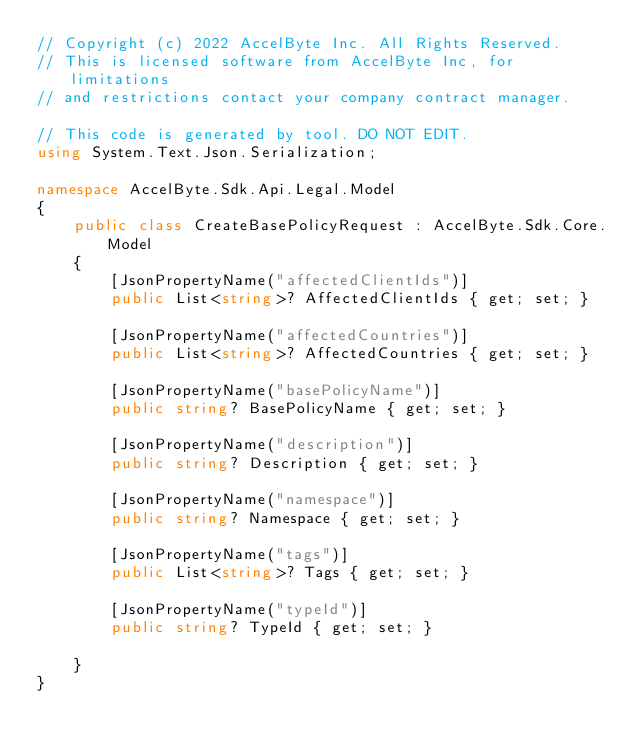<code> <loc_0><loc_0><loc_500><loc_500><_C#_>// Copyright (c) 2022 AccelByte Inc. All Rights Reserved.
// This is licensed software from AccelByte Inc, for limitations
// and restrictions contact your company contract manager.

// This code is generated by tool. DO NOT EDIT.
using System.Text.Json.Serialization;

namespace AccelByte.Sdk.Api.Legal.Model
{
    public class CreateBasePolicyRequest : AccelByte.Sdk.Core.Model
    {
        [JsonPropertyName("affectedClientIds")]
        public List<string>? AffectedClientIds { get; set; }

        [JsonPropertyName("affectedCountries")]
        public List<string>? AffectedCountries { get; set; }

        [JsonPropertyName("basePolicyName")]
        public string? BasePolicyName { get; set; }

        [JsonPropertyName("description")]
        public string? Description { get; set; }

        [JsonPropertyName("namespace")]
        public string? Namespace { get; set; }

        [JsonPropertyName("tags")]
        public List<string>? Tags { get; set; }

        [JsonPropertyName("typeId")]
        public string? TypeId { get; set; }

    }
}</code> 